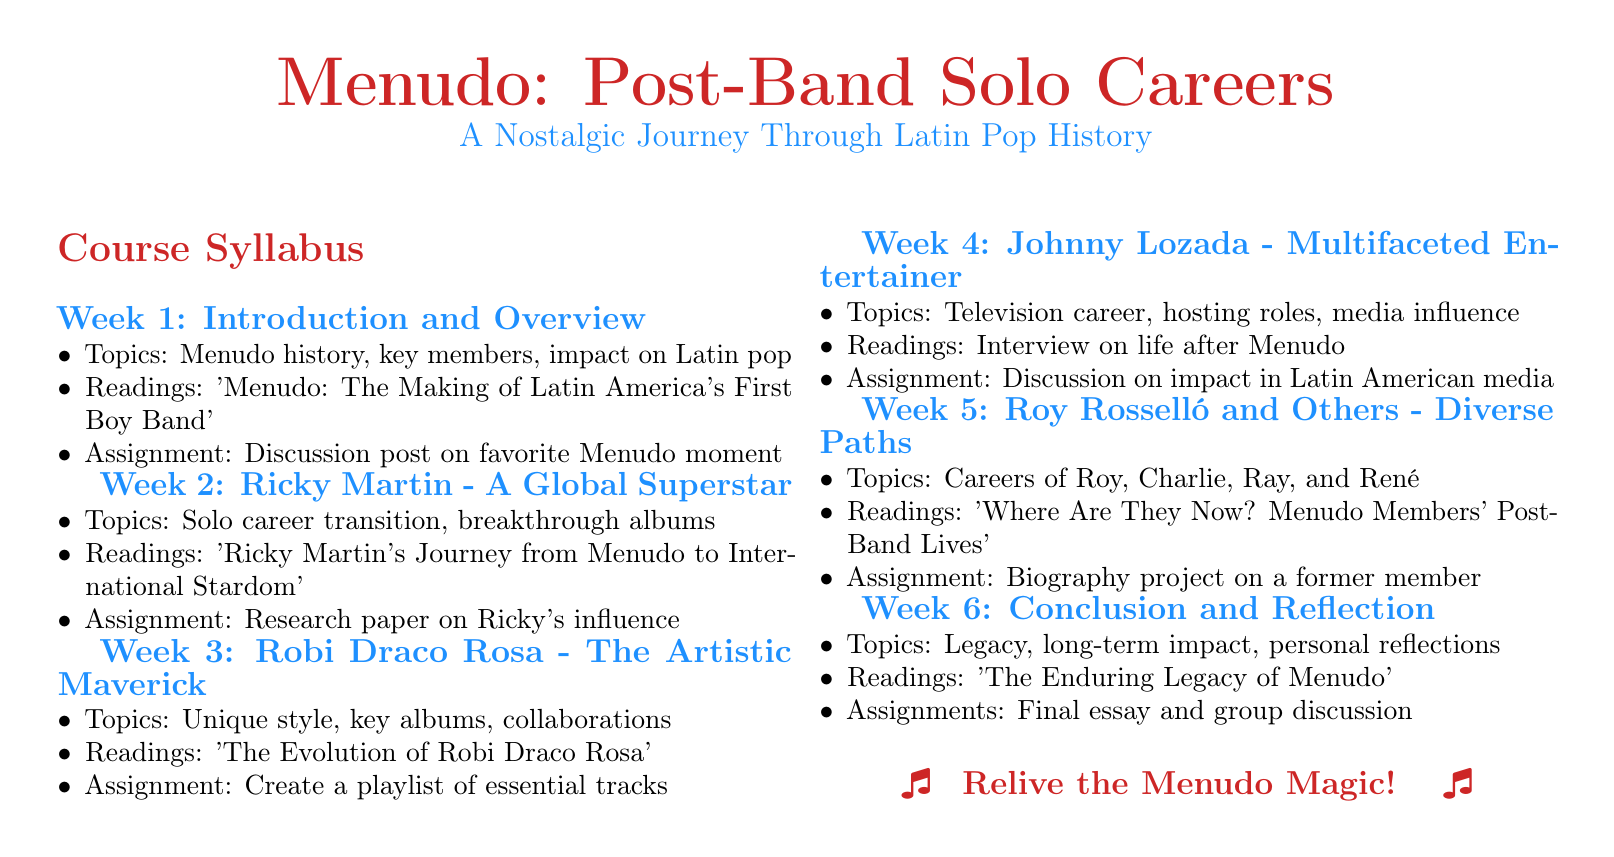What is the title of the syllabus? The title of the syllabus is indicated in a large font at the top of the document.
Answer: Menudo: Post-Band Solo Careers How many weeks are covered in the syllabus? The week headers denote the duration, showing there are six weeks of content.
Answer: 6 What is the main topic of Week 2? The main topic is discussed in the itemized list under Week 2.
Answer: Solo career transition, breakthrough albums Which member's legacy is discussed in Week 4? The topic section explicitly mentions Johnny Lozada's various roles after Menudo in Week 4.
Answer: Johnny Lozada Which reading is assigned for Week 5? The assigned reading for Week 5 is clearly stated in the document.
Answer: Where Are They Now? Menudo Members' Post-Band Lives What assignment is required in Week 6? The document specifies the requirements for the last week, mentioning a final task.
Answer: Final essay and group discussion What color are the week headers? The week headers are mentioned to be in a specific color for emphasis.
Answer: Menudo blue Which artist is highlighted in Week 3? The specific artist discussed in Week 3 is explicitly listed in the topics.
Answer: Robi Draco Rosa 